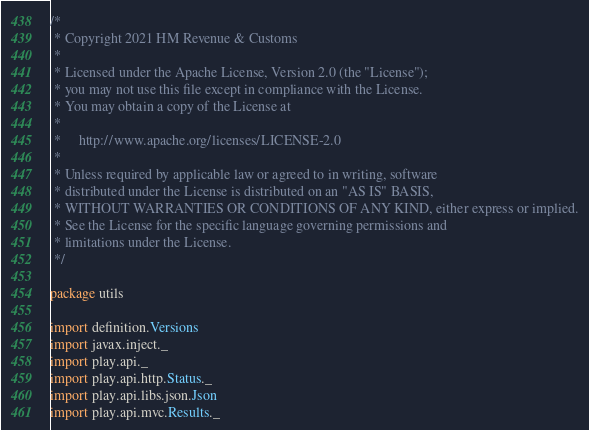Convert code to text. <code><loc_0><loc_0><loc_500><loc_500><_Scala_>/*
 * Copyright 2021 HM Revenue & Customs
 *
 * Licensed under the Apache License, Version 2.0 (the "License");
 * you may not use this file except in compliance with the License.
 * You may obtain a copy of the License at
 *
 *     http://www.apache.org/licenses/LICENSE-2.0
 *
 * Unless required by applicable law or agreed to in writing, software
 * distributed under the License is distributed on an "AS IS" BASIS,
 * WITHOUT WARRANTIES OR CONDITIONS OF ANY KIND, either express or implied.
 * See the License for the specific language governing permissions and
 * limitations under the License.
 */

package utils

import definition.Versions
import javax.inject._
import play.api._
import play.api.http.Status._
import play.api.libs.json.Json
import play.api.mvc.Results._</code> 